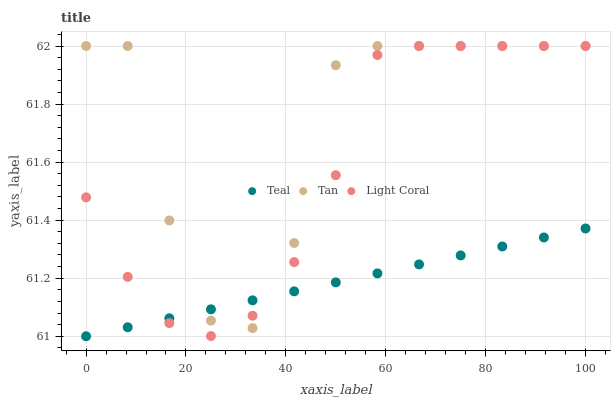Does Teal have the minimum area under the curve?
Answer yes or no. Yes. Does Tan have the maximum area under the curve?
Answer yes or no. Yes. Does Tan have the minimum area under the curve?
Answer yes or no. No. Does Teal have the maximum area under the curve?
Answer yes or no. No. Is Teal the smoothest?
Answer yes or no. Yes. Is Tan the roughest?
Answer yes or no. Yes. Is Tan the smoothest?
Answer yes or no. No. Is Teal the roughest?
Answer yes or no. No. Does Teal have the lowest value?
Answer yes or no. Yes. Does Tan have the lowest value?
Answer yes or no. No. Does Tan have the highest value?
Answer yes or no. Yes. Does Teal have the highest value?
Answer yes or no. No. Does Light Coral intersect Teal?
Answer yes or no. Yes. Is Light Coral less than Teal?
Answer yes or no. No. Is Light Coral greater than Teal?
Answer yes or no. No. 